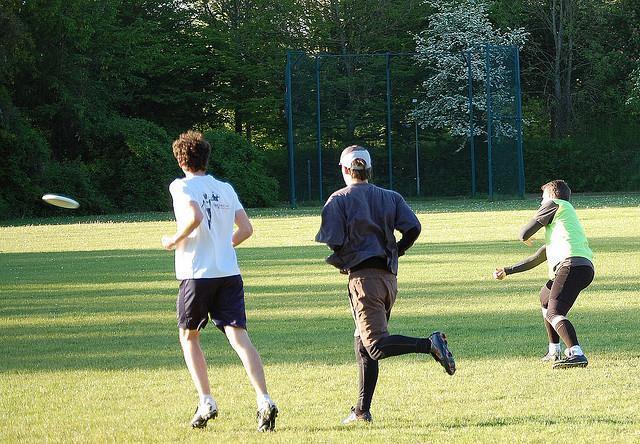How many people are in the photo?
Give a very brief answer. 3. How many people are there?
Give a very brief answer. 3. 